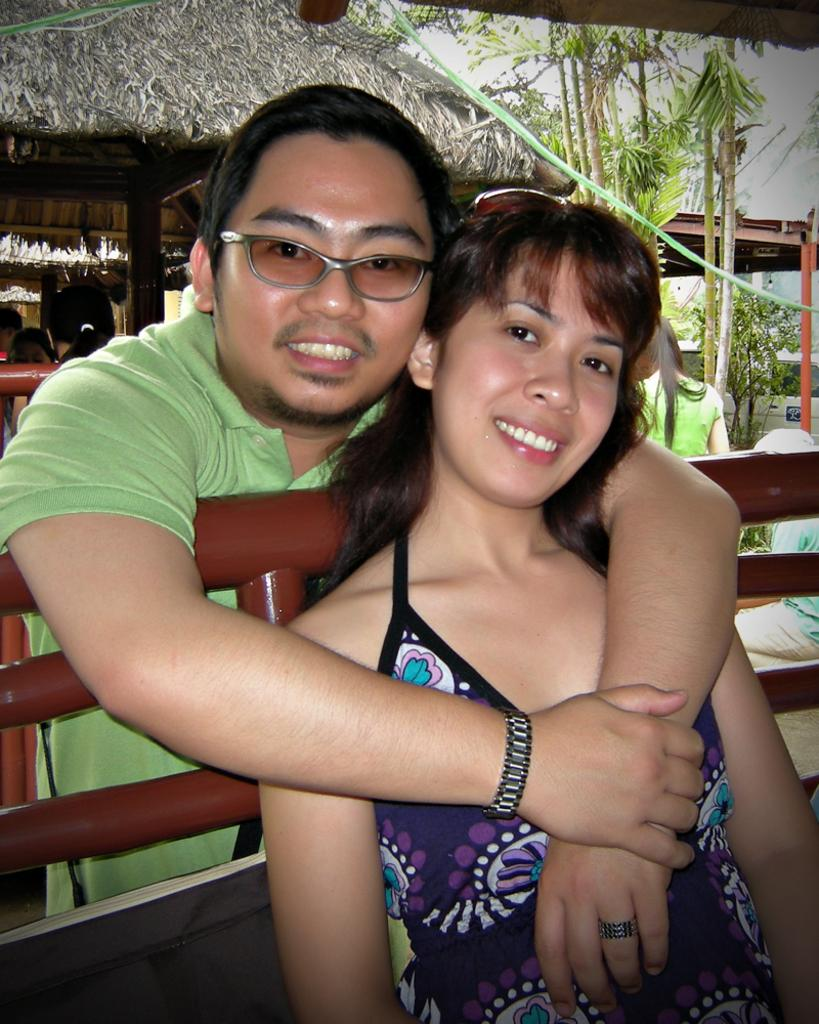How many people are visible in the image? There are two people in the image. What are the people wearing on their heads? The people are wearing goggles. What can be seen in the background of the image? There are more people, plants, a hut, and the sky visible in the background of the image. How can you describe the dresses worn by the two people? The people are wearing different color dresses. What is the price of the balls in the image? There are no balls or any indication of a price in the image. 